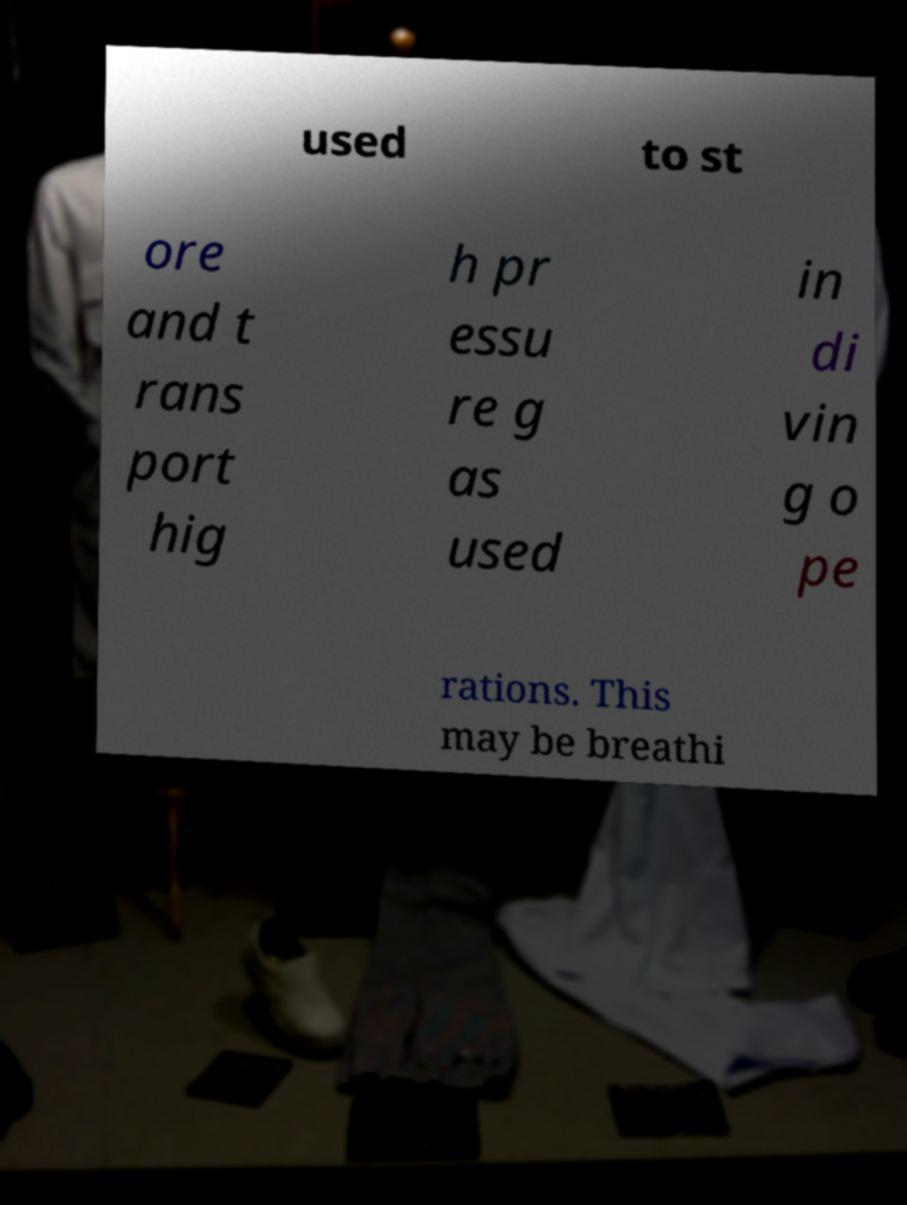Could you assist in decoding the text presented in this image and type it out clearly? used to st ore and t rans port hig h pr essu re g as used in di vin g o pe rations. This may be breathi 